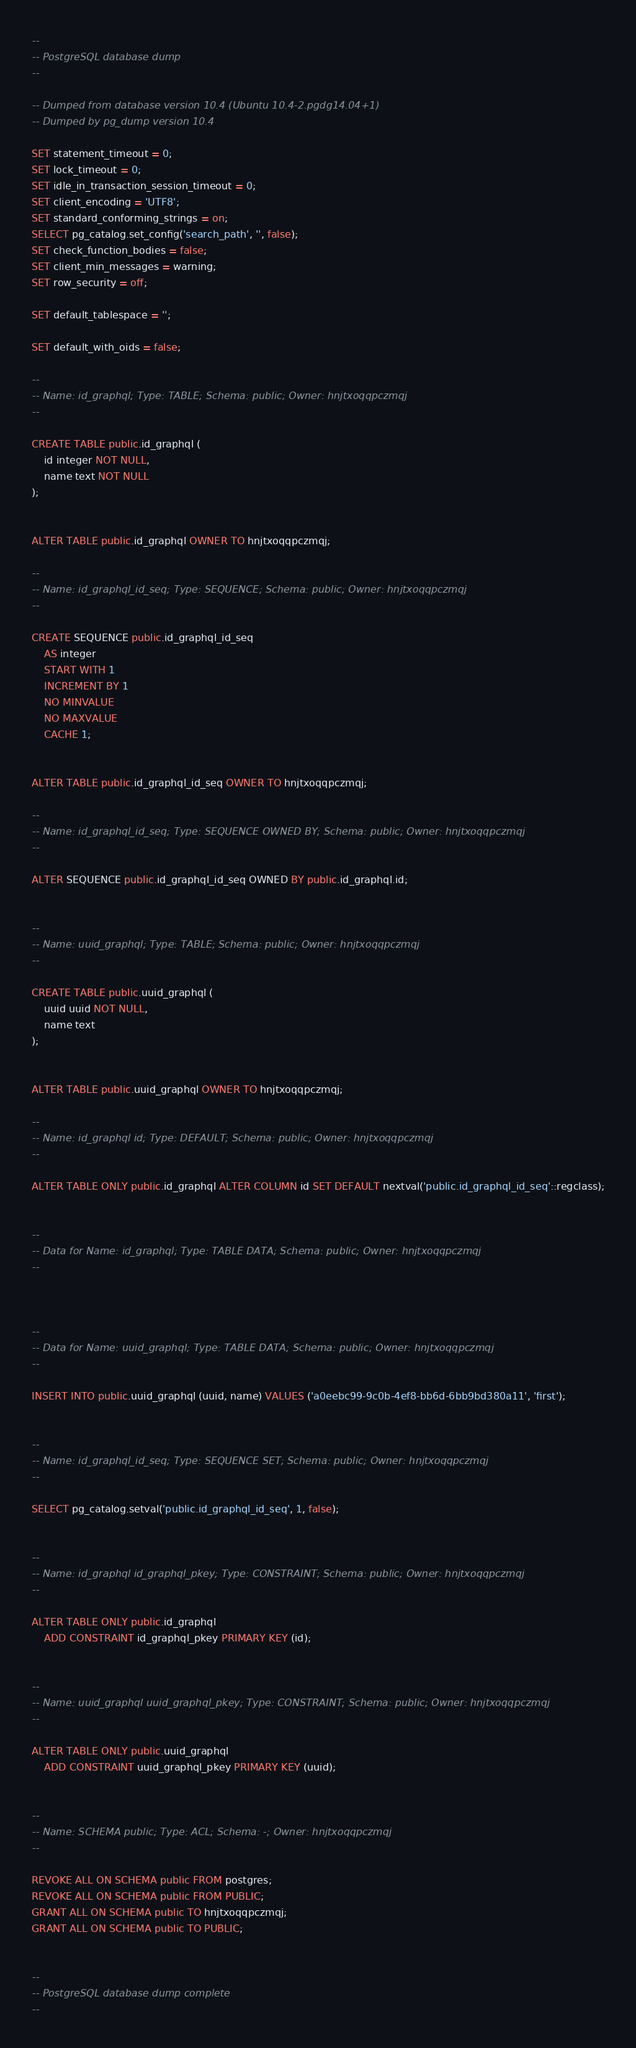Convert code to text. <code><loc_0><loc_0><loc_500><loc_500><_SQL_>--
-- PostgreSQL database dump
--

-- Dumped from database version 10.4 (Ubuntu 10.4-2.pgdg14.04+1)
-- Dumped by pg_dump version 10.4

SET statement_timeout = 0;
SET lock_timeout = 0;
SET idle_in_transaction_session_timeout = 0;
SET client_encoding = 'UTF8';
SET standard_conforming_strings = on;
SELECT pg_catalog.set_config('search_path', '', false);
SET check_function_bodies = false;
SET client_min_messages = warning;
SET row_security = off;

SET default_tablespace = '';

SET default_with_oids = false;

--
-- Name: id_graphql; Type: TABLE; Schema: public; Owner: hnjtxoqqpczmqj
--

CREATE TABLE public.id_graphql (
    id integer NOT NULL,
    name text NOT NULL
);


ALTER TABLE public.id_graphql OWNER TO hnjtxoqqpczmqj;

--
-- Name: id_graphql_id_seq; Type: SEQUENCE; Schema: public; Owner: hnjtxoqqpczmqj
--

CREATE SEQUENCE public.id_graphql_id_seq
    AS integer
    START WITH 1
    INCREMENT BY 1
    NO MINVALUE
    NO MAXVALUE
    CACHE 1;


ALTER TABLE public.id_graphql_id_seq OWNER TO hnjtxoqqpczmqj;

--
-- Name: id_graphql_id_seq; Type: SEQUENCE OWNED BY; Schema: public; Owner: hnjtxoqqpczmqj
--

ALTER SEQUENCE public.id_graphql_id_seq OWNED BY public.id_graphql.id;


--
-- Name: uuid_graphql; Type: TABLE; Schema: public; Owner: hnjtxoqqpczmqj
--

CREATE TABLE public.uuid_graphql (
    uuid uuid NOT NULL,
    name text
);


ALTER TABLE public.uuid_graphql OWNER TO hnjtxoqqpczmqj;

--
-- Name: id_graphql id; Type: DEFAULT; Schema: public; Owner: hnjtxoqqpczmqj
--

ALTER TABLE ONLY public.id_graphql ALTER COLUMN id SET DEFAULT nextval('public.id_graphql_id_seq'::regclass);


--
-- Data for Name: id_graphql; Type: TABLE DATA; Schema: public; Owner: hnjtxoqqpczmqj
--



--
-- Data for Name: uuid_graphql; Type: TABLE DATA; Schema: public; Owner: hnjtxoqqpczmqj
--

INSERT INTO public.uuid_graphql (uuid, name) VALUES ('a0eebc99-9c0b-4ef8-bb6d-6bb9bd380a11', 'first');


--
-- Name: id_graphql_id_seq; Type: SEQUENCE SET; Schema: public; Owner: hnjtxoqqpczmqj
--

SELECT pg_catalog.setval('public.id_graphql_id_seq', 1, false);


--
-- Name: id_graphql id_graphql_pkey; Type: CONSTRAINT; Schema: public; Owner: hnjtxoqqpczmqj
--

ALTER TABLE ONLY public.id_graphql
    ADD CONSTRAINT id_graphql_pkey PRIMARY KEY (id);


--
-- Name: uuid_graphql uuid_graphql_pkey; Type: CONSTRAINT; Schema: public; Owner: hnjtxoqqpczmqj
--

ALTER TABLE ONLY public.uuid_graphql
    ADD CONSTRAINT uuid_graphql_pkey PRIMARY KEY (uuid);


--
-- Name: SCHEMA public; Type: ACL; Schema: -; Owner: hnjtxoqqpczmqj
--

REVOKE ALL ON SCHEMA public FROM postgres;
REVOKE ALL ON SCHEMA public FROM PUBLIC;
GRANT ALL ON SCHEMA public TO hnjtxoqqpczmqj;
GRANT ALL ON SCHEMA public TO PUBLIC;


--
-- PostgreSQL database dump complete
--

</code> 